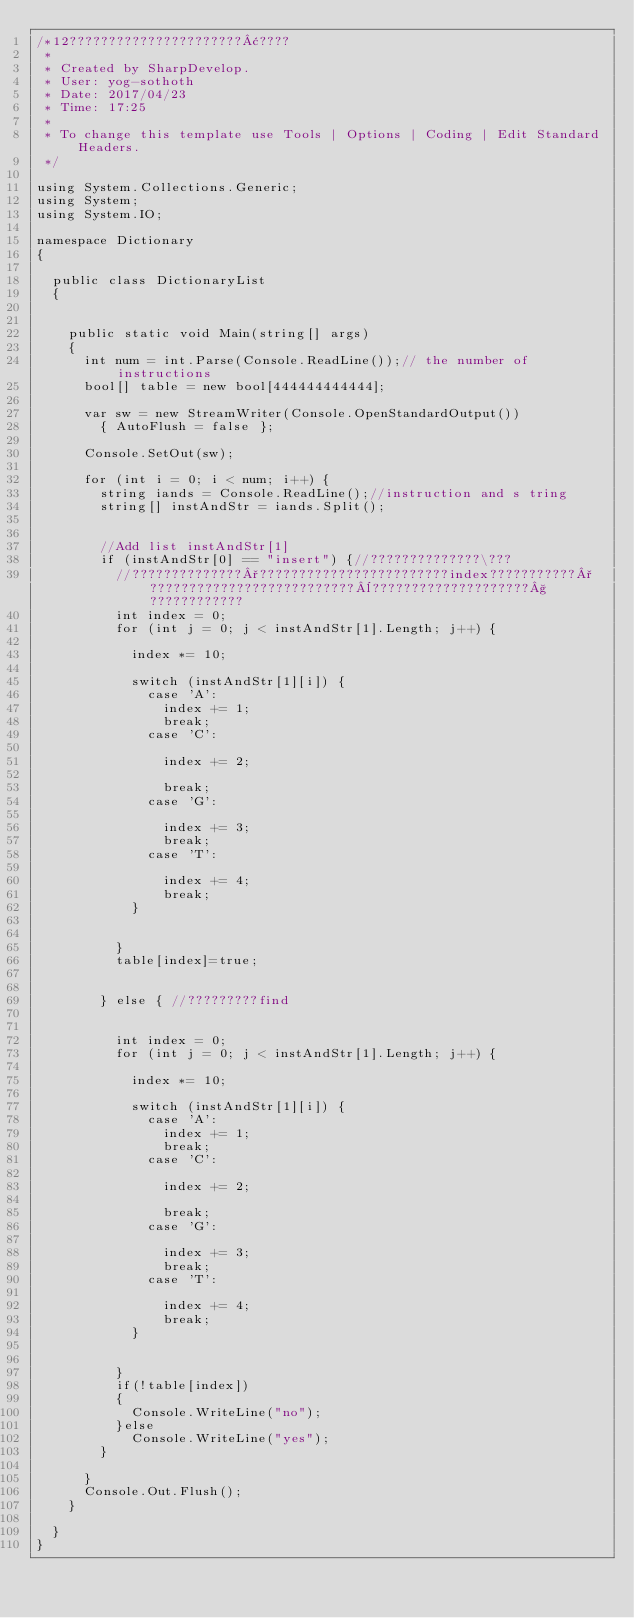<code> <loc_0><loc_0><loc_500><loc_500><_C#_>/*12??????????????????????¢????
 * 
 * Created by SharpDevelop.
 * User: yog-sothoth
 * Date: 2017/04/23
 * Time: 17:25
 * 
 * To change this template use Tools | Options | Coding | Edit Standard Headers.
 */

using System.Collections.Generic;
using System;
using System.IO;

namespace Dictionary
{
	
	public class DictionaryList
	{
		
		
		public static void Main(string[] args)
		{		
			int num = int.Parse(Console.ReadLine());// the number of instructions
			bool[] table = new bool[444444444444];
		
			var sw = new StreamWriter(Console.OpenStandardOutput())
	    	{ AutoFlush = false };
			
			Console.SetOut(sw);
			
			for (int i = 0; i < num; i++) {
				string iands = Console.ReadLine();//instruction and s tring
				string[] instAndStr = iands.Split();
			
				
				//Add list instAndStr[1]		
				if (instAndStr[0] == "insert") {//??????????????\???
					//??????????????°????????????????????????index???????????°??????????????????????????¨????????????????????§????????????
					int index = 0;
					for (int j = 0; j < instAndStr[1].Length; j++) {
			
						index *= 10;
				
						switch (instAndStr[1][i]) {
							case 'A':
								index += 1;
								break;
							case 'C':
						
								index += 2;
						
								break;
							case 'G':
						
								index += 3;
								break;
							case 'T':
						
								index += 4;
								break;			
						}
						
		
					}
					table[index]=true;
		
					
				} else { //?????????find
					
					
					int index = 0;
					for (int j = 0; j < instAndStr[1].Length; j++) {
			
						index *= 10;
				
						switch (instAndStr[1][i]) {
							case 'A':
								index += 1;
								break;
							case 'C':
						
								index += 2;
						
								break;
							case 'G':
						
								index += 3;
								break;
							case 'T':
						
								index += 4;
								break;			
						}
						
		
					}
					if(!table[index])
					{
						Console.WriteLine("no");
					}else
						Console.WriteLine("yes");
				}
				
			}
			Console.Out.Flush();
		}
		
	}
}</code> 